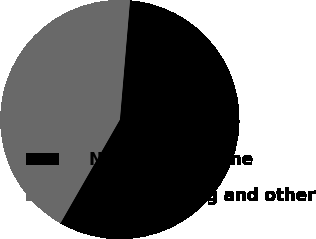<chart> <loc_0><loc_0><loc_500><loc_500><pie_chart><fcel>Net (loss) income<fcel>Restructuring and other<nl><fcel>56.94%<fcel>43.06%<nl></chart> 